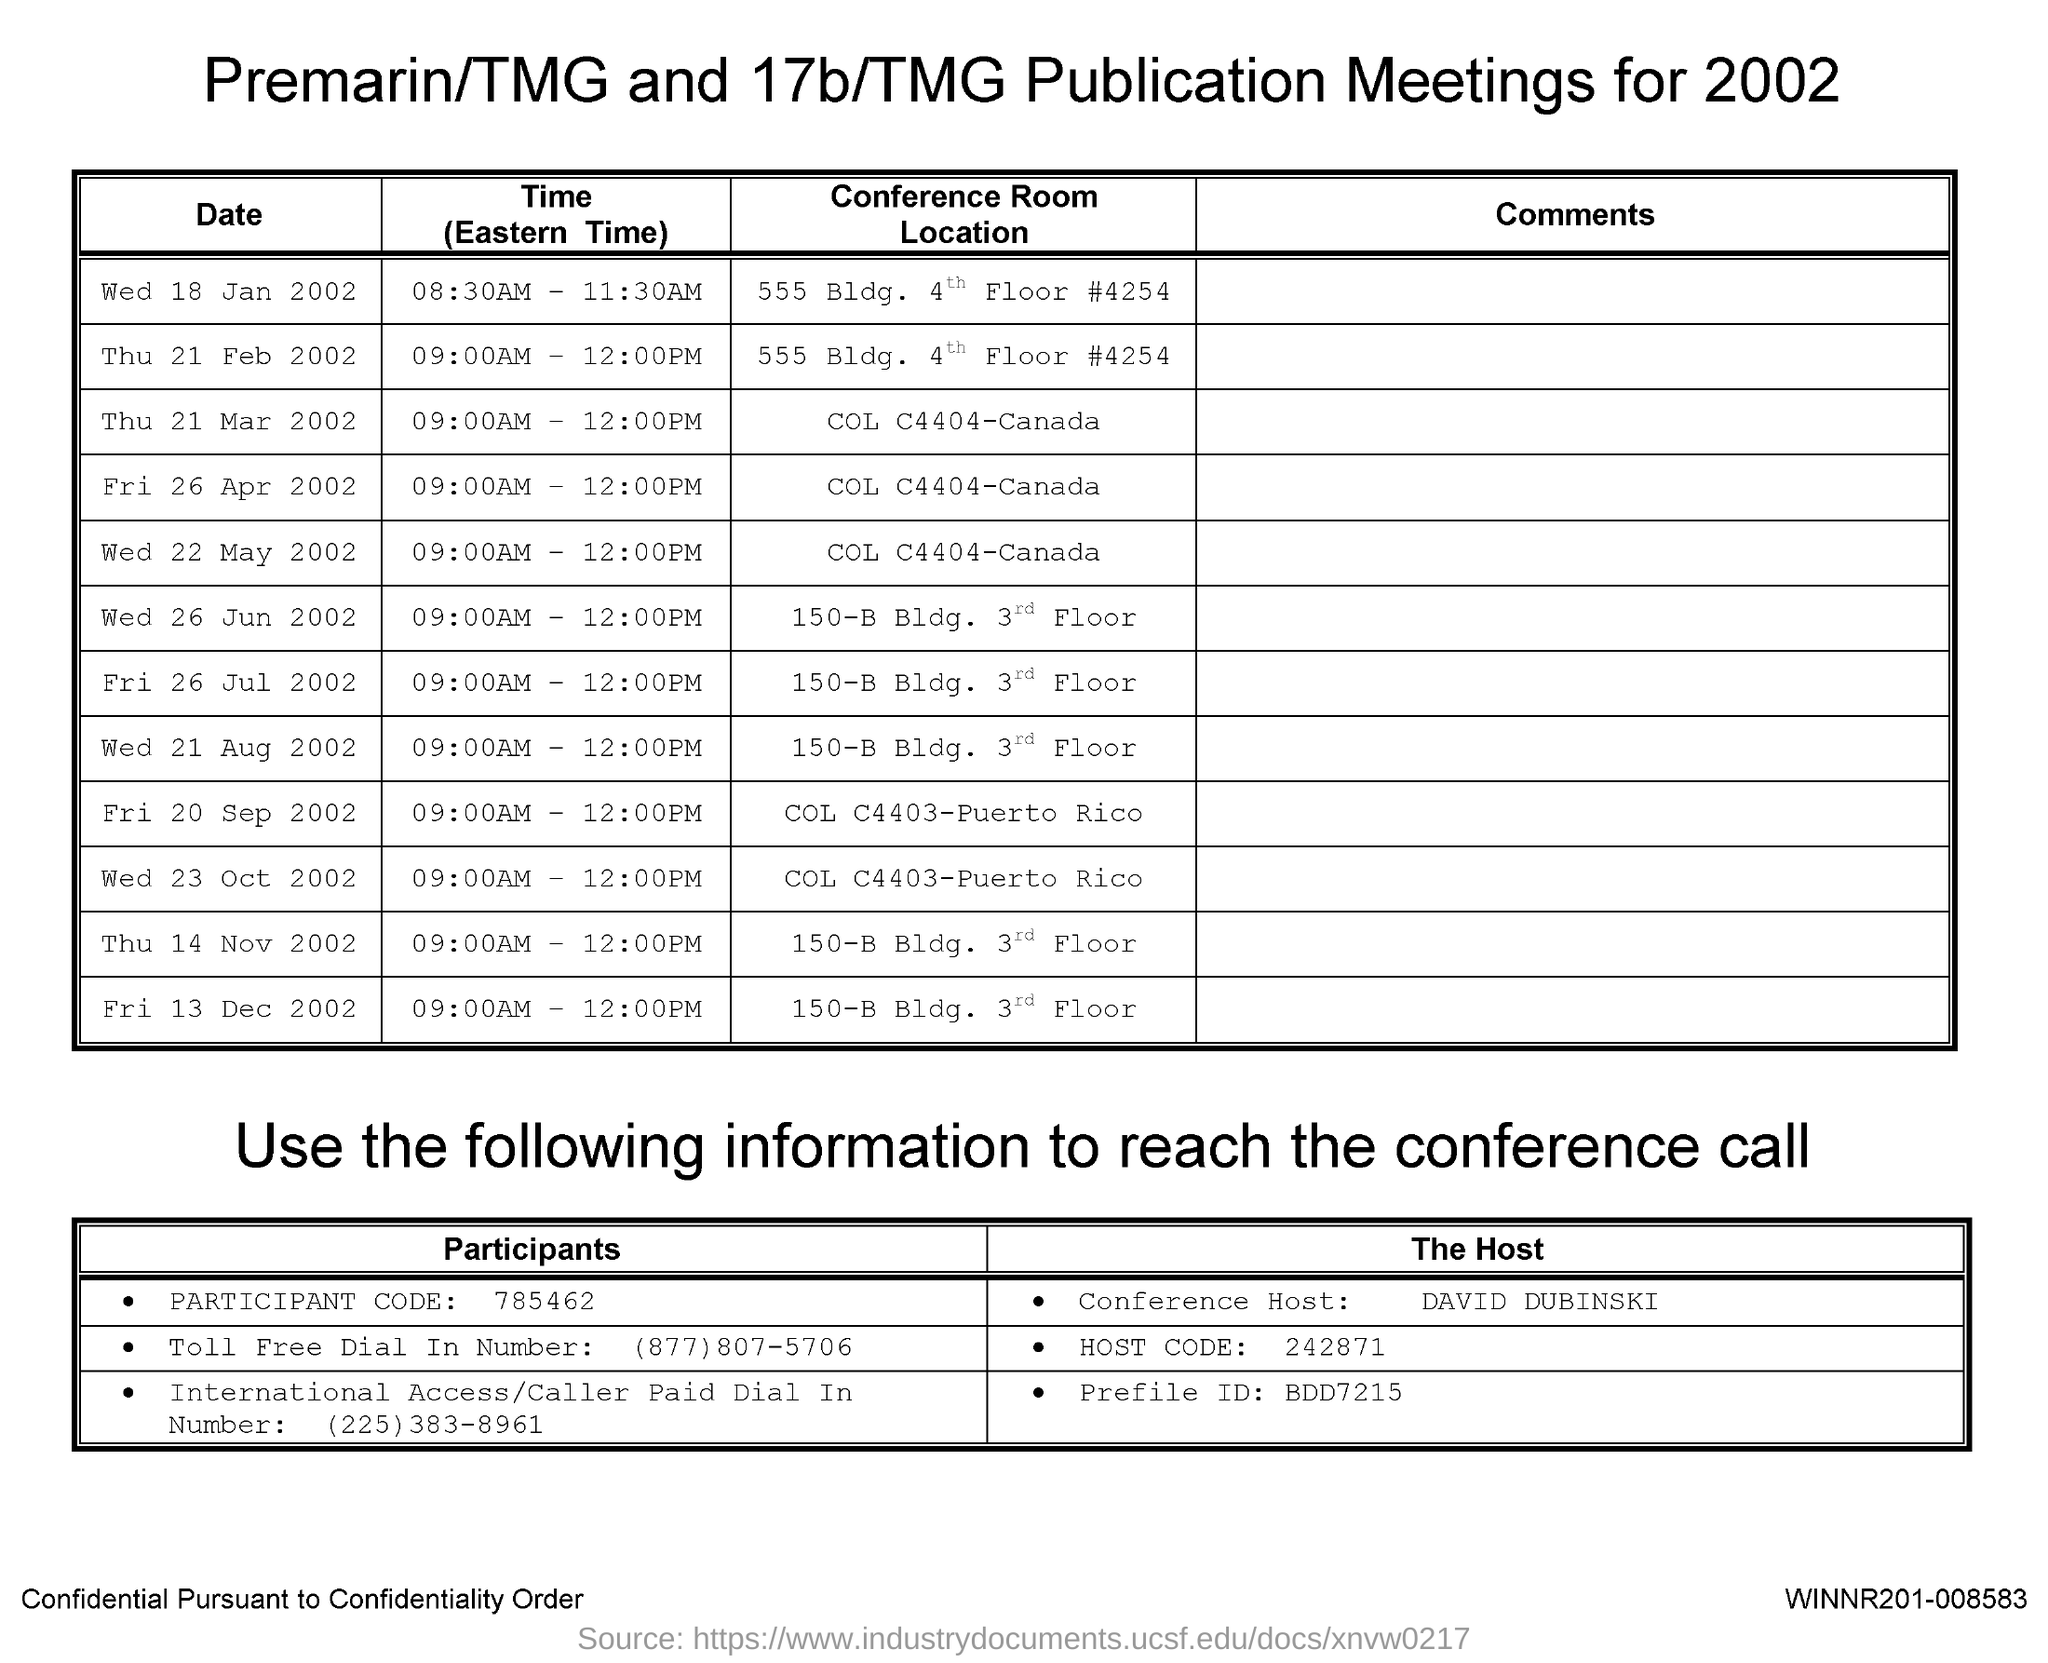What is the Participant Code given in this document?
Offer a very short reply. 785462. Who is the Conference Host?
Your response must be concise. David Dubinski. What is the Host Code given in this document?
Ensure brevity in your answer.  242871. At what time, the Premarin/TMG and 17b/TMG Publication Meeeting is held on Wed 18 Jan 2002?
Make the answer very short. 08:30AM - 11:30AM. 